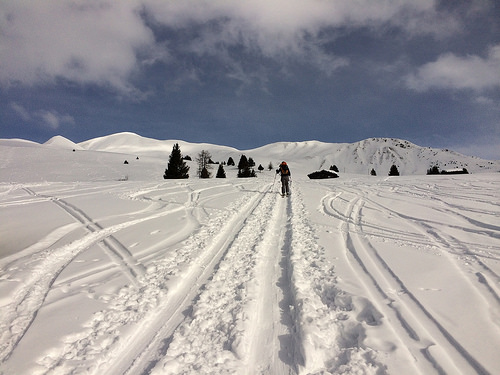<image>
Is the snow on the sky? No. The snow is not positioned on the sky. They may be near each other, but the snow is not supported by or resting on top of the sky. 